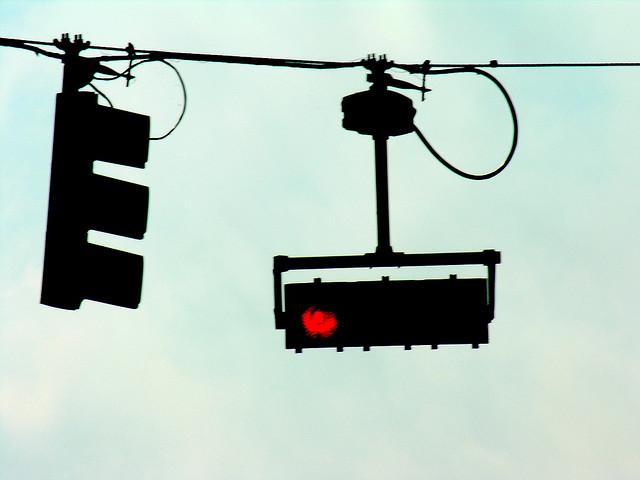How many colored lights are on the signal to the left?
Quick response, please. 3. Are there clouds in the sky?
Answer briefly. Yes. What does red mean?
Write a very short answer. Stop. 